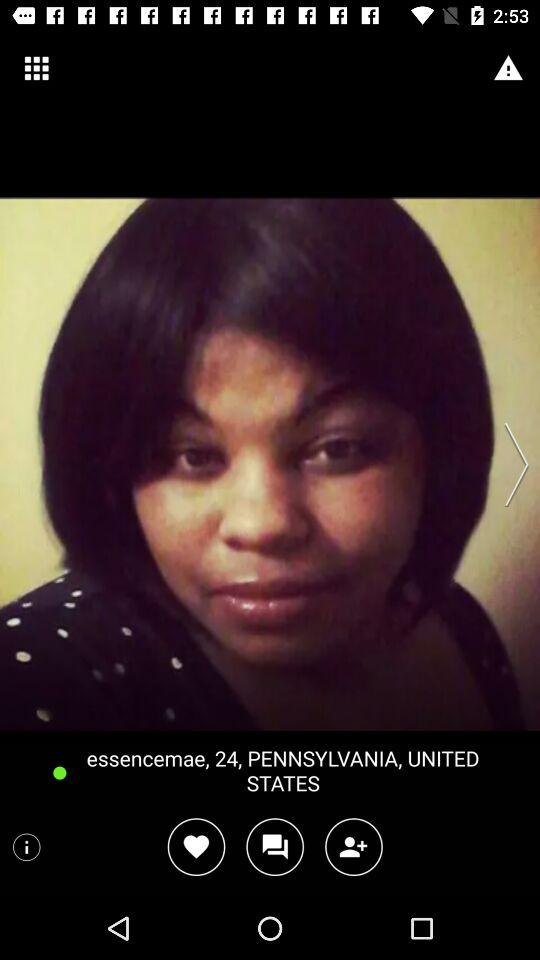What is the given age? The given age is 24. 